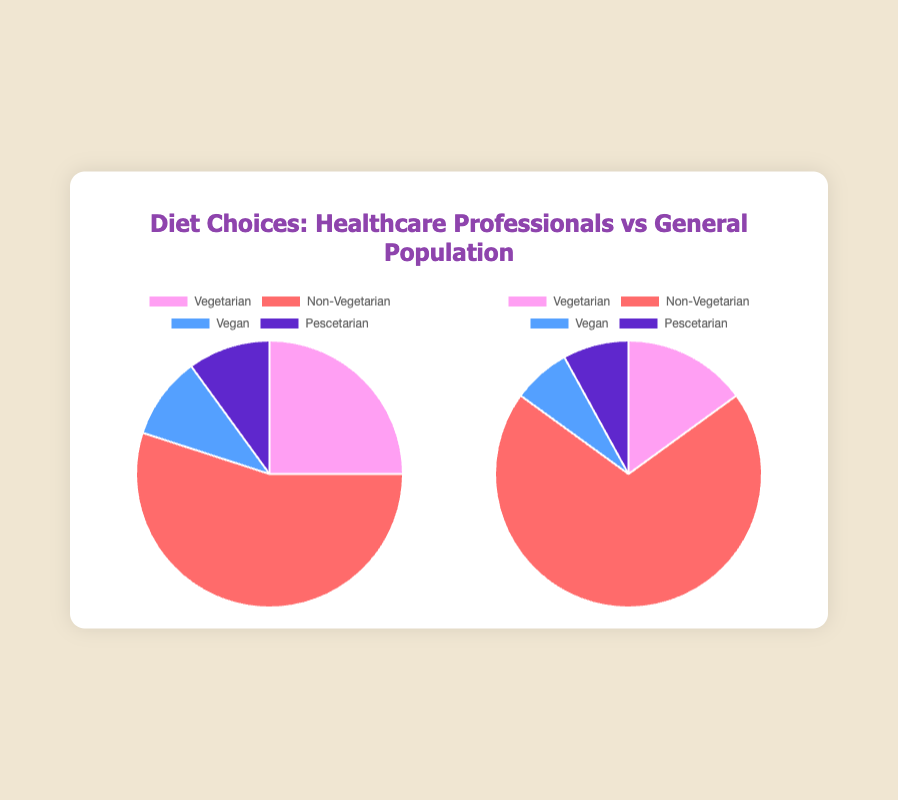Which group has a higher percentage of vegetarians? The healthcare professionals have a higher percentage of vegetarians at 25% compared to the general population's 15%.
Answer: Healthcare professionals What is the combined percentage of vegan and pescetarian diet choices in the general population? The vegan percentage for the general population is 7%, and the pescetarian percentage is 8%. Combining these gives 7% + 8% = 15%.
Answer: 15% Which diet type has the largest difference in percentage between healthcare professionals and the general population? The largest difference is in the non-vegetarian category, where healthcare professionals are 55% and the general population is 70%. The difference is 70% - 55% = 15%.
Answer: Non-vegetarian How much more prevalent is the non-vegetarian diet in the general population compared to healthcare professionals? The general population has 70% non-vegetarians, while healthcare professionals have 55%. The difference is 70% - 55% = 15%.
Answer: 15% more What percentage of healthcare professionals follow either a vegan or vegetarian diet? Adding the vegetarian (25%) and vegan (10%) percentages for healthcare professionals gives 25% + 10% = 35%.
Answer: 35% Are there more pescetarians in the healthcare professionals group or the general population? Both groups have the same percentage of pescetarians at 10% for healthcare professionals and 8% for the general population.
Answer: Healthcare professionals Which group has the highest percentage of vegans? Healthcare professionals have a higher percentage of vegans at 10% compared to 7% in the general population.
Answer: Healthcare professionals In terms of diet, what is the most common choice for both groups? For both groups, the most common diet choice is non-vegetarian, with 55% for healthcare professionals and 70% for the general population.
Answer: Non-vegetarian Which group has a greater proportion of pescetarian diet followers? Healthcare professionals have a higher proportion of pescetarians at 10% compared to 8% in the general population.
Answer: Healthcare professionals If you combine vegetarians and vegans, which group has a higher combined percentage? For healthcare professionals, vegetarians and vegans combine to 25% + 10% = 35%. For the general population, they combine to 15% + 7% = 22%. Therefore, healthcare professionals have a higher combined percentage.
Answer: Healthcare professionals 